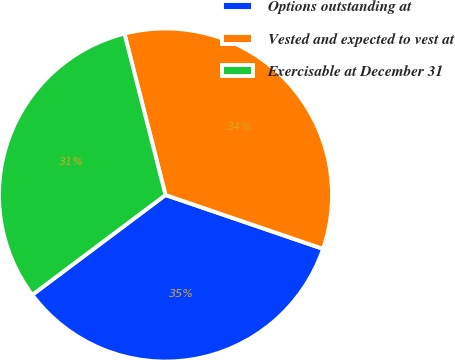Convert chart to OTSL. <chart><loc_0><loc_0><loc_500><loc_500><pie_chart><fcel>Options outstanding at<fcel>Vested and expected to vest at<fcel>Exercisable at December 31<nl><fcel>34.52%<fcel>34.21%<fcel>31.27%<nl></chart> 